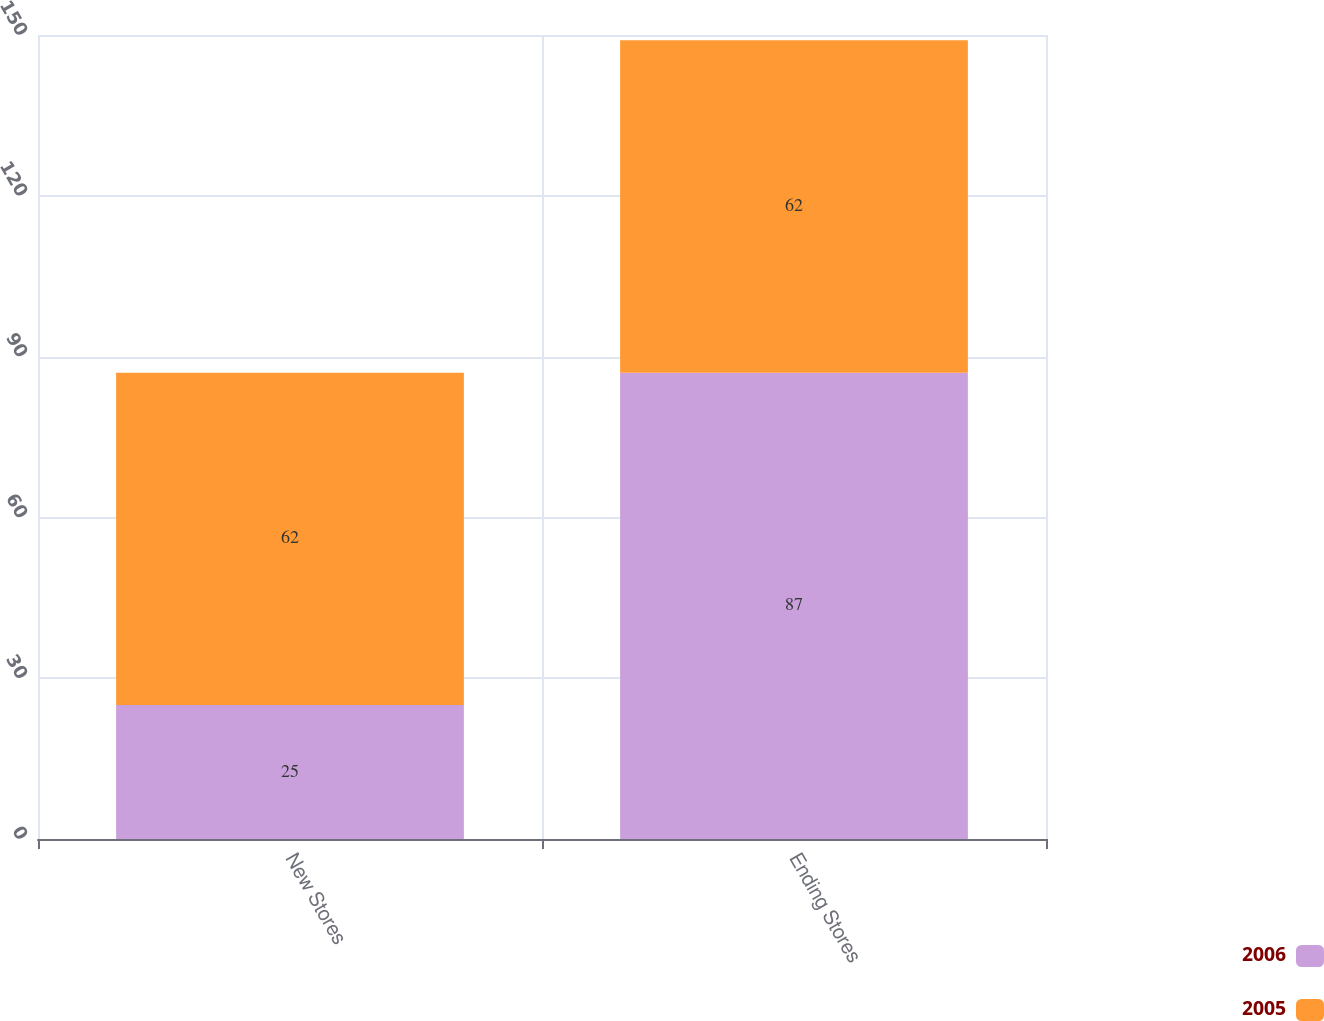<chart> <loc_0><loc_0><loc_500><loc_500><stacked_bar_chart><ecel><fcel>New Stores<fcel>Ending Stores<nl><fcel>2006<fcel>25<fcel>87<nl><fcel>2005<fcel>62<fcel>62<nl></chart> 